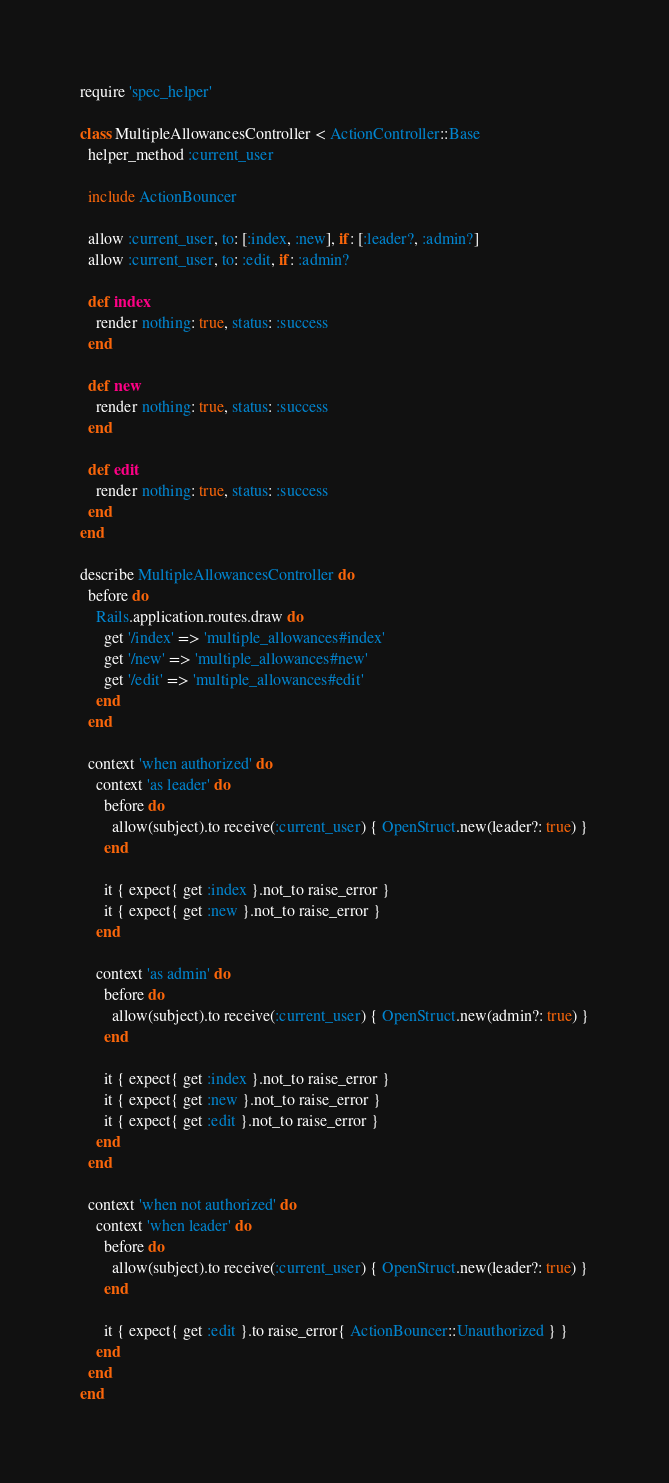<code> <loc_0><loc_0><loc_500><loc_500><_Ruby_>require 'spec_helper'

class MultipleAllowancesController < ActionController::Base
  helper_method :current_user

  include ActionBouncer

  allow :current_user, to: [:index, :new], if: [:leader?, :admin?]
  allow :current_user, to: :edit, if: :admin?

  def index
    render nothing: true, status: :success
  end

  def new
    render nothing: true, status: :success
  end

  def edit
    render nothing: true, status: :success
  end
end

describe MultipleAllowancesController do
  before do
    Rails.application.routes.draw do
      get '/index' => 'multiple_allowances#index'
      get '/new' => 'multiple_allowances#new'
      get '/edit' => 'multiple_allowances#edit'
    end
  end

  context 'when authorized' do
    context 'as leader' do
      before do
        allow(subject).to receive(:current_user) { OpenStruct.new(leader?: true) }
      end

      it { expect{ get :index }.not_to raise_error }
      it { expect{ get :new }.not_to raise_error }
    end

    context 'as admin' do
      before do
        allow(subject).to receive(:current_user) { OpenStruct.new(admin?: true) }
      end

      it { expect{ get :index }.not_to raise_error }
      it { expect{ get :new }.not_to raise_error }
      it { expect{ get :edit }.not_to raise_error }
    end
  end

  context 'when not authorized' do
    context 'when leader' do
      before do
        allow(subject).to receive(:current_user) { OpenStruct.new(leader?: true) }
      end

      it { expect{ get :edit }.to raise_error{ ActionBouncer::Unauthorized } }
    end
  end
end

</code> 